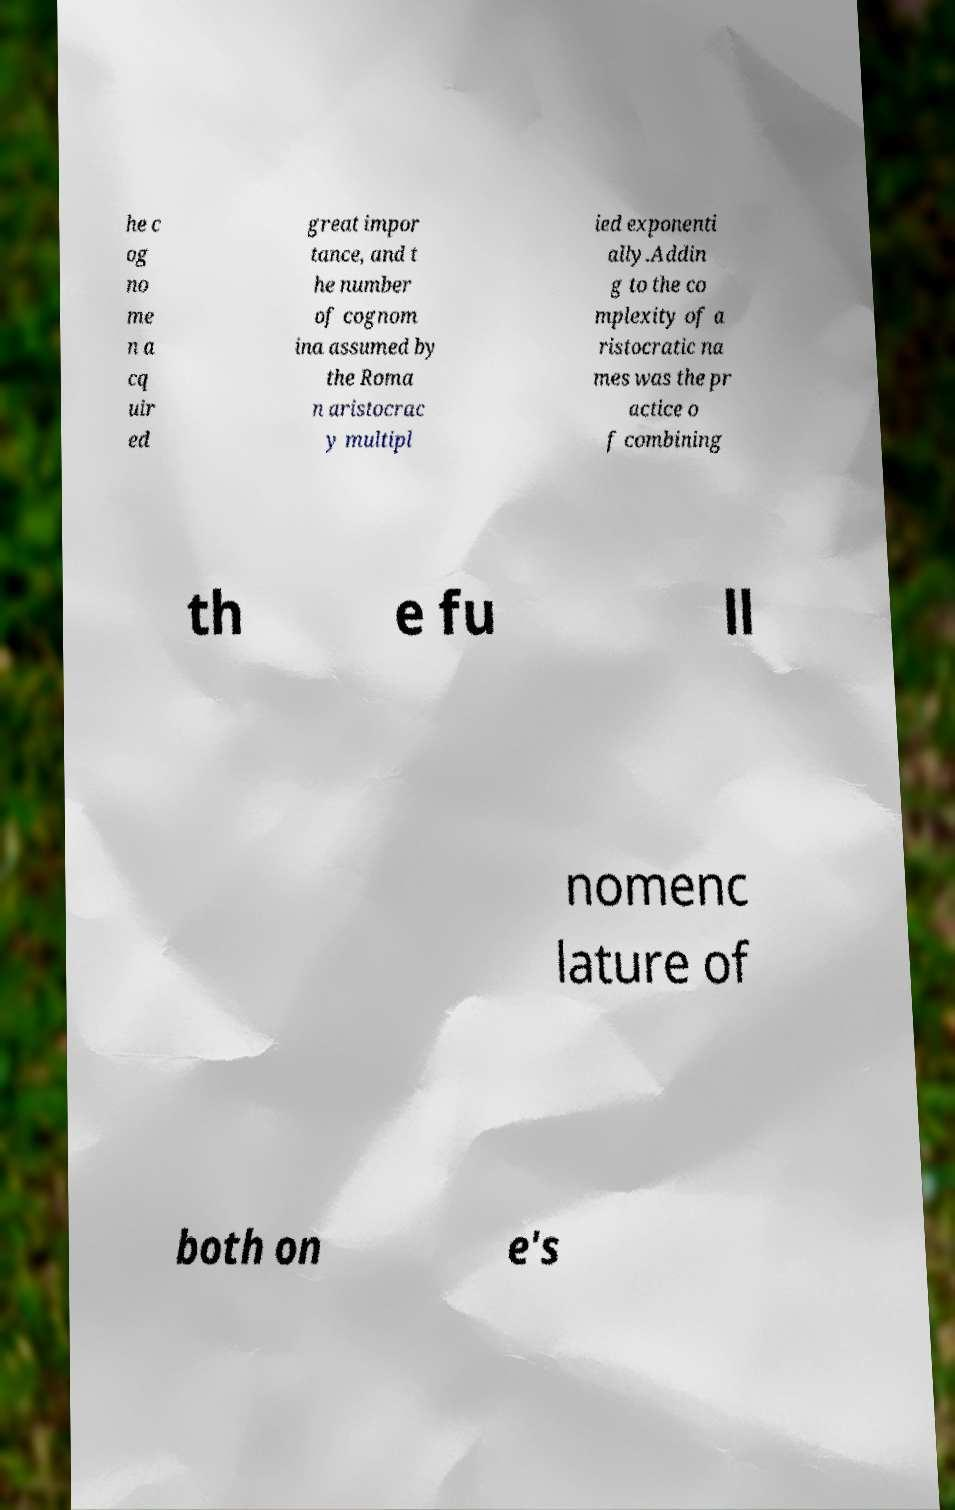Please read and relay the text visible in this image. What does it say? he c og no me n a cq uir ed great impor tance, and t he number of cognom ina assumed by the Roma n aristocrac y multipl ied exponenti ally.Addin g to the co mplexity of a ristocratic na mes was the pr actice o f combining th e fu ll nomenc lature of both on e's 